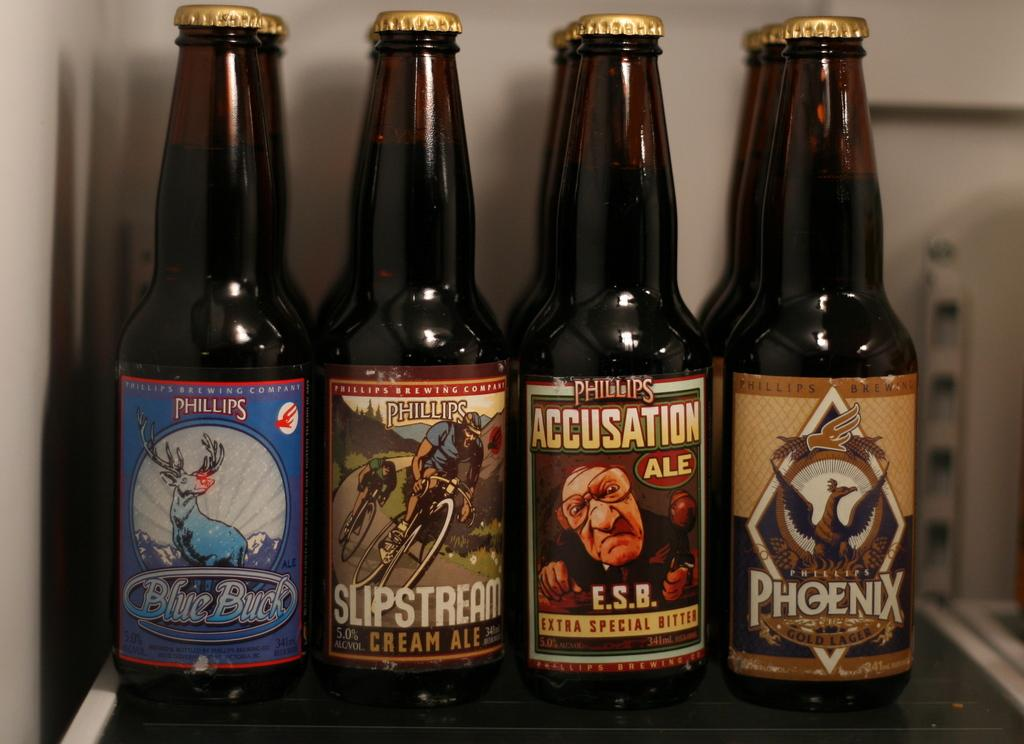<image>
Relay a brief, clear account of the picture shown. A Blue Buck bottle is next to several other bottles. 